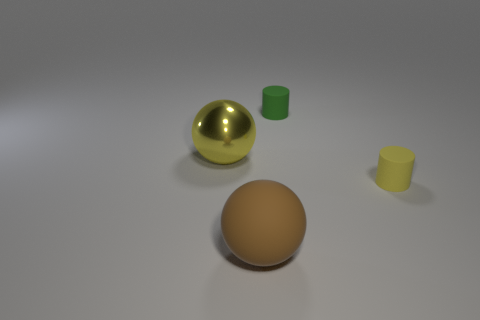Add 2 large red metallic balls. How many objects exist? 6 Subtract 1 yellow balls. How many objects are left? 3 Subtract all tiny matte cylinders. Subtract all brown matte balls. How many objects are left? 1 Add 4 small yellow objects. How many small yellow objects are left? 5 Add 2 big yellow things. How many big yellow things exist? 3 